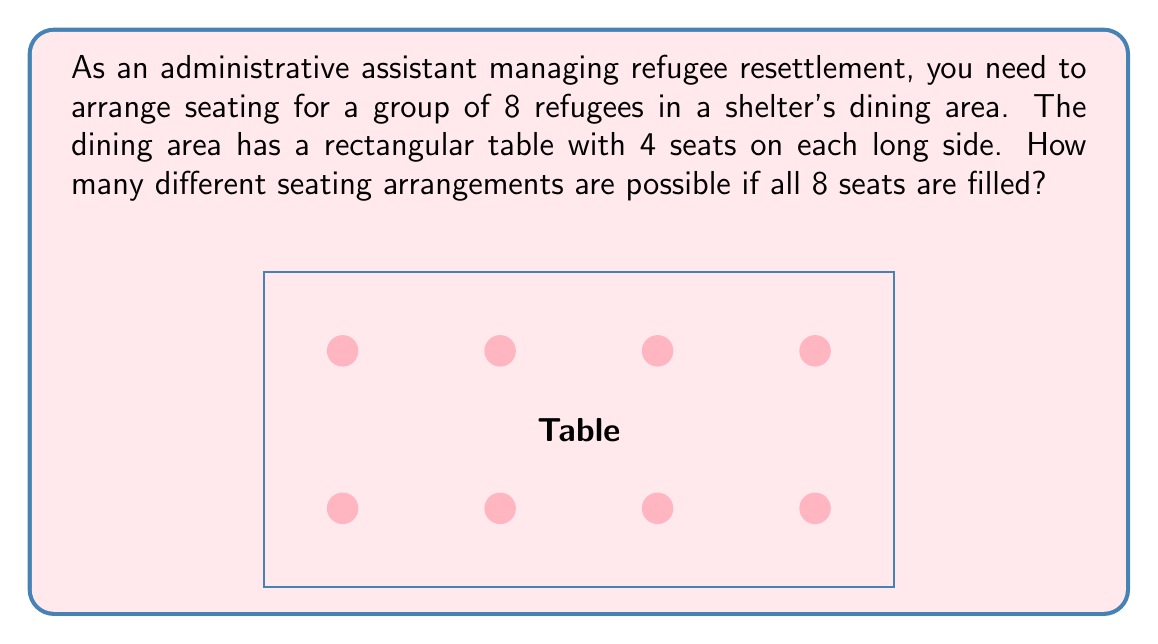Could you help me with this problem? Let's approach this step-by-step:

1) We have 8 refugees to be seated in 8 specific positions. This is a permutation problem.

2) The number of permutations of n distinct objects is given by n!

3) In this case, n = 8, so we need to calculate 8!

4) 8! = 8 × 7 × 6 × 5 × 4 × 3 × 2 × 1

5) Let's calculate this:
   $$8! = 8 \times 7 \times 6 \times 5 \times 4 \times 3 \times 2 \times 1 = 40,320$$

6) Therefore, there are 40,320 different possible seating arrangements.

This large number demonstrates why efficient management of seating arrangements can be crucial in a refugee shelter, as even small changes in the number of people can lead to significantly different logistics.
Answer: 40,320 